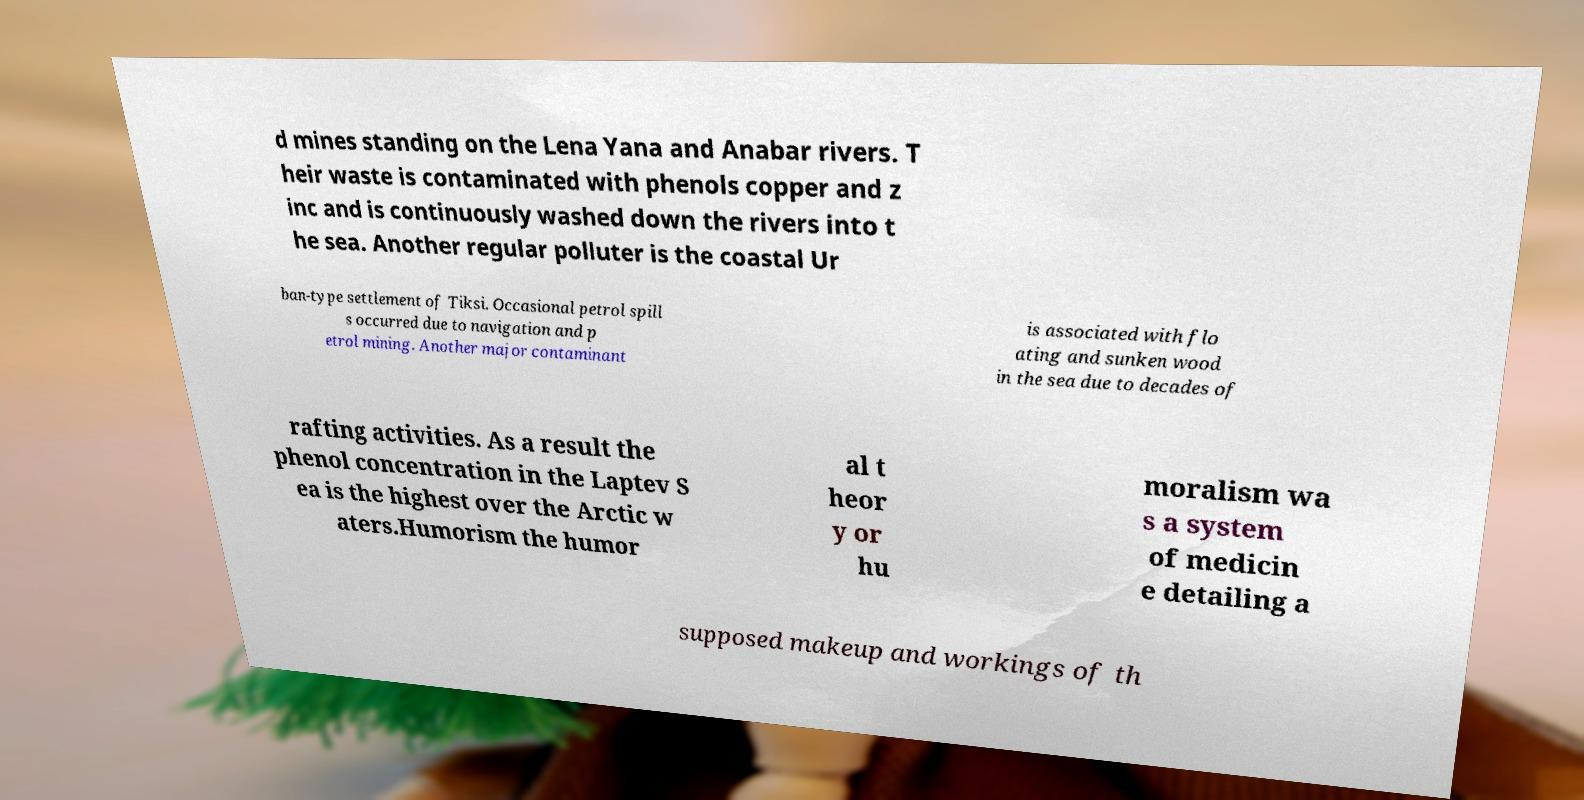Can you accurately transcribe the text from the provided image for me? d mines standing on the Lena Yana and Anabar rivers. T heir waste is contaminated with phenols copper and z inc and is continuously washed down the rivers into t he sea. Another regular polluter is the coastal Ur ban-type settlement of Tiksi. Occasional petrol spill s occurred due to navigation and p etrol mining. Another major contaminant is associated with flo ating and sunken wood in the sea due to decades of rafting activities. As a result the phenol concentration in the Laptev S ea is the highest over the Arctic w aters.Humorism the humor al t heor y or hu moralism wa s a system of medicin e detailing a supposed makeup and workings of th 